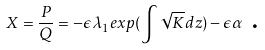Convert formula to latex. <formula><loc_0><loc_0><loc_500><loc_500>X = \frac { P } { Q } = - \epsilon \lambda _ { 1 } e x p ( \int \sqrt { K } d z ) - \epsilon \alpha \text { .}</formula> 